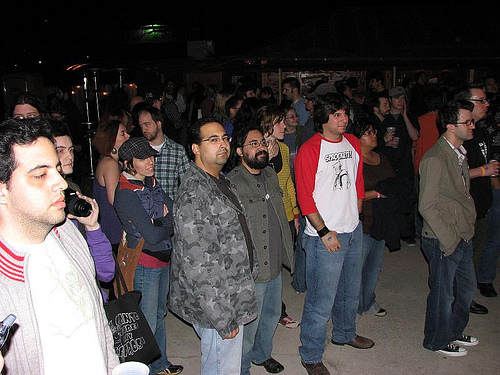<image>
Is the shoe behind the floor? No. The shoe is not behind the floor. From this viewpoint, the shoe appears to be positioned elsewhere in the scene. 